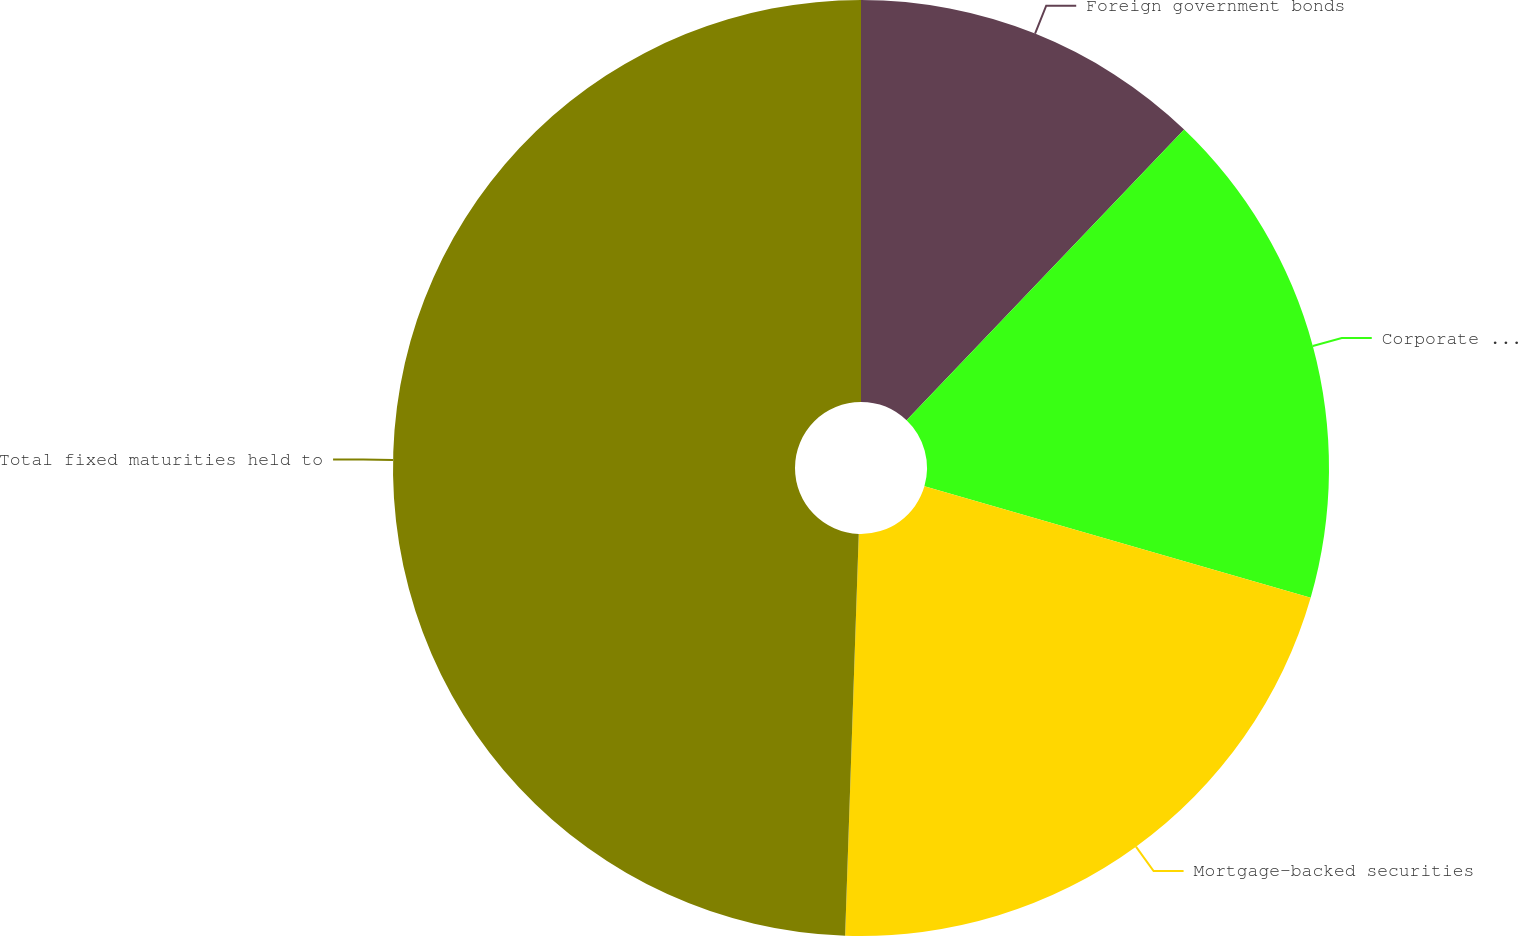<chart> <loc_0><loc_0><loc_500><loc_500><pie_chart><fcel>Foreign government bonds<fcel>Corporate securities<fcel>Mortgage-backed securities<fcel>Total fixed maturities held to<nl><fcel>12.13%<fcel>17.34%<fcel>21.07%<fcel>49.46%<nl></chart> 